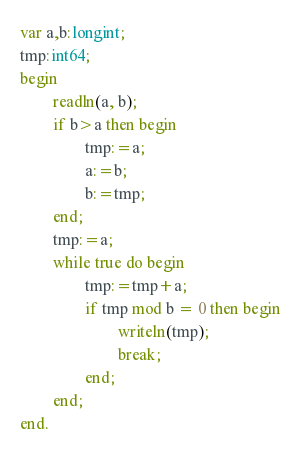<code> <loc_0><loc_0><loc_500><loc_500><_Pascal_>var a,b:longint;
tmp:int64;
begin
        readln(a, b);
        if b>a then begin
                tmp:=a;
                a:=b;
                b:=tmp;
        end;
        tmp:=a;
        while true do begin
                tmp:=tmp+a;
                if tmp mod b = 0 then begin
                        writeln(tmp);
                        break;
                end;
        end;
end.
</code> 